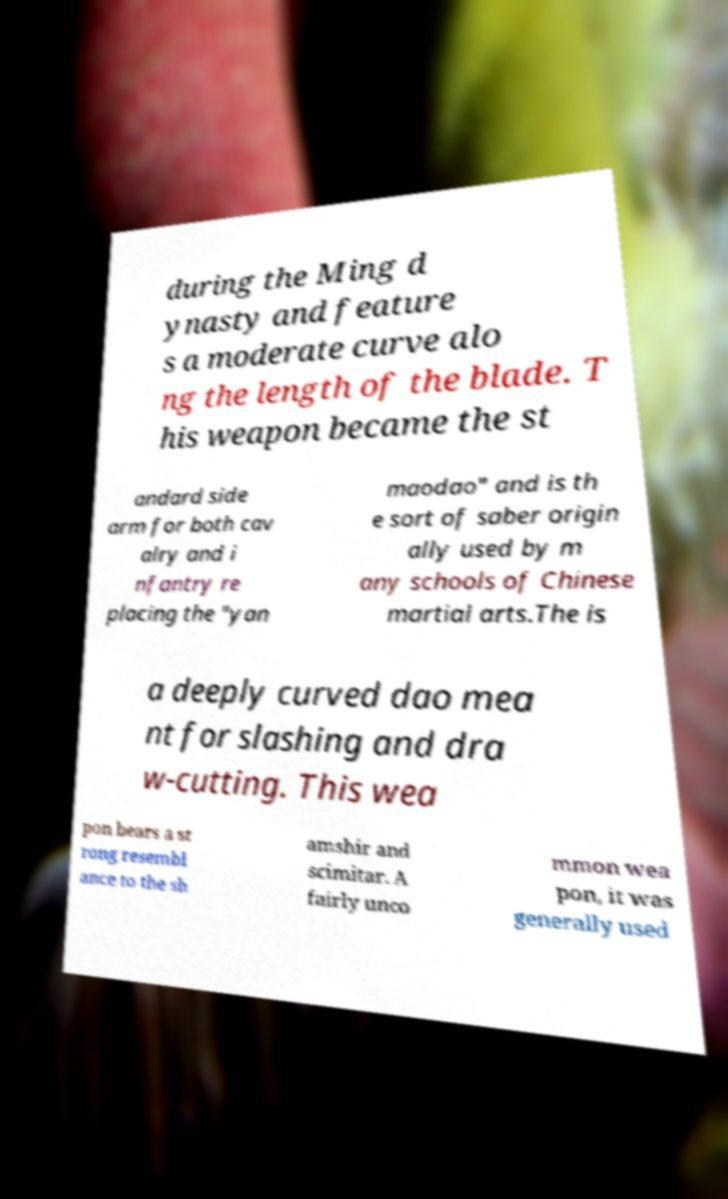Please identify and transcribe the text found in this image. during the Ming d ynasty and feature s a moderate curve alo ng the length of the blade. T his weapon became the st andard side arm for both cav alry and i nfantry re placing the "yan maodao" and is th e sort of saber origin ally used by m any schools of Chinese martial arts.The is a deeply curved dao mea nt for slashing and dra w-cutting. This wea pon bears a st rong resembl ance to the sh amshir and scimitar. A fairly unco mmon wea pon, it was generally used 